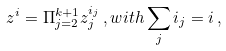<formula> <loc_0><loc_0><loc_500><loc_500>z ^ { i } = \Pi _ { j = 2 } ^ { k + 1 } z _ { j } ^ { i _ { j } } \, , w i t h \sum _ { j } i _ { j } = i \, ,</formula> 